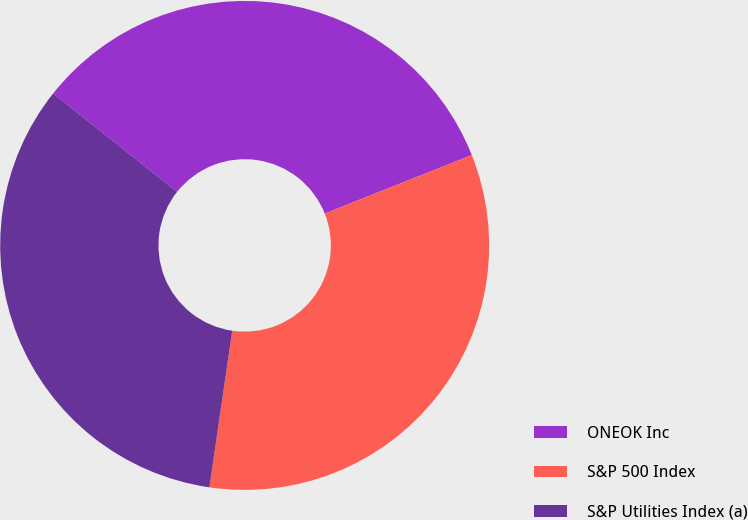Convert chart. <chart><loc_0><loc_0><loc_500><loc_500><pie_chart><fcel>ONEOK Inc<fcel>S&P 500 Index<fcel>S&P Utilities Index (a)<nl><fcel>33.3%<fcel>33.33%<fcel>33.37%<nl></chart> 